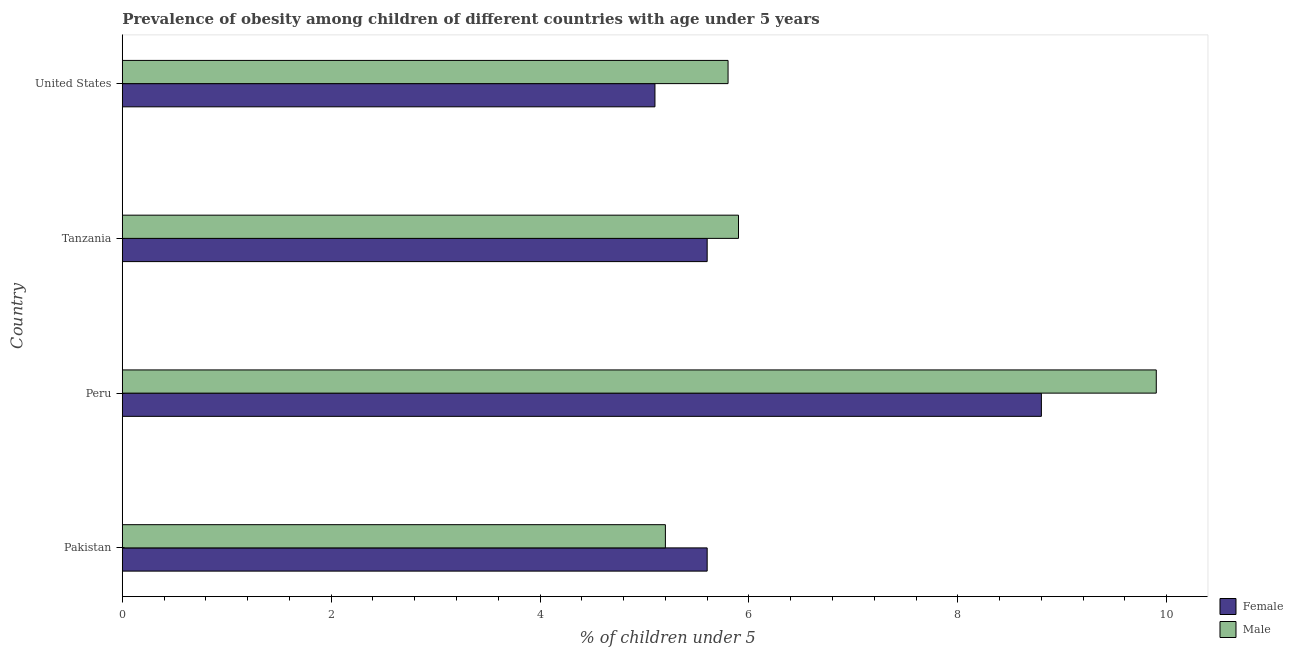How many different coloured bars are there?
Your answer should be compact. 2. How many groups of bars are there?
Your answer should be very brief. 4. How many bars are there on the 3rd tick from the bottom?
Provide a short and direct response. 2. What is the percentage of obese male children in Peru?
Your answer should be compact. 9.9. Across all countries, what is the maximum percentage of obese female children?
Give a very brief answer. 8.8. Across all countries, what is the minimum percentage of obese female children?
Keep it short and to the point. 5.1. In which country was the percentage of obese male children minimum?
Your response must be concise. Pakistan. What is the total percentage of obese female children in the graph?
Make the answer very short. 25.1. What is the difference between the percentage of obese female children in Peru and that in Tanzania?
Keep it short and to the point. 3.2. What is the difference between the percentage of obese male children in Tanzania and the percentage of obese female children in Peru?
Your response must be concise. -2.9. What is the average percentage of obese female children per country?
Provide a succinct answer. 6.28. In how many countries, is the percentage of obese male children greater than 6.4 %?
Keep it short and to the point. 1. What is the ratio of the percentage of obese male children in Tanzania to that in United States?
Provide a succinct answer. 1.02. Is the difference between the percentage of obese male children in Peru and Tanzania greater than the difference between the percentage of obese female children in Peru and Tanzania?
Give a very brief answer. Yes. What is the difference between the highest and the lowest percentage of obese female children?
Provide a short and direct response. 3.7. What does the 1st bar from the top in Peru represents?
Your answer should be compact. Male. What does the 1st bar from the bottom in Pakistan represents?
Your answer should be compact. Female. How many bars are there?
Make the answer very short. 8. How many countries are there in the graph?
Your response must be concise. 4. Are the values on the major ticks of X-axis written in scientific E-notation?
Ensure brevity in your answer.  No. Does the graph contain any zero values?
Offer a very short reply. No. Does the graph contain grids?
Offer a very short reply. No. Where does the legend appear in the graph?
Keep it short and to the point. Bottom right. How many legend labels are there?
Give a very brief answer. 2. What is the title of the graph?
Keep it short and to the point. Prevalence of obesity among children of different countries with age under 5 years. Does "Primary education" appear as one of the legend labels in the graph?
Your answer should be very brief. No. What is the label or title of the X-axis?
Make the answer very short.  % of children under 5. What is the label or title of the Y-axis?
Provide a succinct answer. Country. What is the  % of children under 5 of Female in Pakistan?
Ensure brevity in your answer.  5.6. What is the  % of children under 5 of Male in Pakistan?
Offer a very short reply. 5.2. What is the  % of children under 5 of Female in Peru?
Keep it short and to the point. 8.8. What is the  % of children under 5 in Male in Peru?
Your answer should be compact. 9.9. What is the  % of children under 5 in Female in Tanzania?
Your response must be concise. 5.6. What is the  % of children under 5 in Male in Tanzania?
Ensure brevity in your answer.  5.9. What is the  % of children under 5 in Female in United States?
Ensure brevity in your answer.  5.1. What is the  % of children under 5 in Male in United States?
Keep it short and to the point. 5.8. Across all countries, what is the maximum  % of children under 5 in Female?
Your answer should be compact. 8.8. Across all countries, what is the maximum  % of children under 5 in Male?
Your answer should be compact. 9.9. Across all countries, what is the minimum  % of children under 5 of Female?
Provide a succinct answer. 5.1. Across all countries, what is the minimum  % of children under 5 in Male?
Make the answer very short. 5.2. What is the total  % of children under 5 in Female in the graph?
Your answer should be compact. 25.1. What is the total  % of children under 5 in Male in the graph?
Your response must be concise. 26.8. What is the difference between the  % of children under 5 in Female in Pakistan and that in Peru?
Offer a very short reply. -3.2. What is the difference between the  % of children under 5 of Male in Pakistan and that in Peru?
Provide a succinct answer. -4.7. What is the difference between the  % of children under 5 in Male in Pakistan and that in Tanzania?
Ensure brevity in your answer.  -0.7. What is the difference between the  % of children under 5 of Male in Pakistan and that in United States?
Your response must be concise. -0.6. What is the difference between the  % of children under 5 in Female in Peru and that in Tanzania?
Offer a terse response. 3.2. What is the difference between the  % of children under 5 in Male in Peru and that in Tanzania?
Your answer should be compact. 4. What is the difference between the  % of children under 5 of Female in Tanzania and that in United States?
Give a very brief answer. 0.5. What is the difference between the  % of children under 5 in Female in Pakistan and the  % of children under 5 in Male in Tanzania?
Your answer should be compact. -0.3. What is the difference between the  % of children under 5 in Female in Pakistan and the  % of children under 5 in Male in United States?
Provide a succinct answer. -0.2. What is the difference between the  % of children under 5 in Female in Tanzania and the  % of children under 5 in Male in United States?
Provide a short and direct response. -0.2. What is the average  % of children under 5 of Female per country?
Offer a very short reply. 6.28. What is the difference between the  % of children under 5 of Female and  % of children under 5 of Male in Pakistan?
Offer a terse response. 0.4. What is the difference between the  % of children under 5 in Female and  % of children under 5 in Male in Tanzania?
Your answer should be compact. -0.3. What is the ratio of the  % of children under 5 in Female in Pakistan to that in Peru?
Provide a short and direct response. 0.64. What is the ratio of the  % of children under 5 of Male in Pakistan to that in Peru?
Keep it short and to the point. 0.53. What is the ratio of the  % of children under 5 in Male in Pakistan to that in Tanzania?
Provide a succinct answer. 0.88. What is the ratio of the  % of children under 5 in Female in Pakistan to that in United States?
Provide a short and direct response. 1.1. What is the ratio of the  % of children under 5 of Male in Pakistan to that in United States?
Offer a very short reply. 0.9. What is the ratio of the  % of children under 5 of Female in Peru to that in Tanzania?
Provide a succinct answer. 1.57. What is the ratio of the  % of children under 5 of Male in Peru to that in Tanzania?
Your answer should be compact. 1.68. What is the ratio of the  % of children under 5 in Female in Peru to that in United States?
Keep it short and to the point. 1.73. What is the ratio of the  % of children under 5 of Male in Peru to that in United States?
Offer a terse response. 1.71. What is the ratio of the  % of children under 5 in Female in Tanzania to that in United States?
Ensure brevity in your answer.  1.1. What is the ratio of the  % of children under 5 of Male in Tanzania to that in United States?
Keep it short and to the point. 1.02. What is the difference between the highest and the second highest  % of children under 5 in Female?
Give a very brief answer. 3.2. What is the difference between the highest and the lowest  % of children under 5 of Female?
Provide a succinct answer. 3.7. What is the difference between the highest and the lowest  % of children under 5 of Male?
Offer a very short reply. 4.7. 